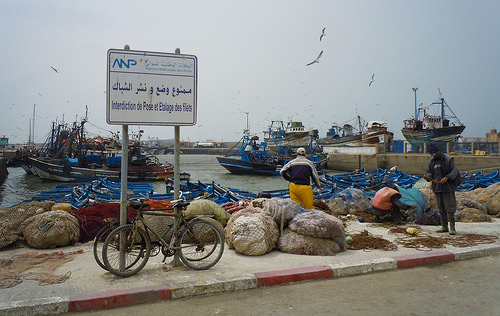<image>
Is there a green water on the sea gull? No. The green water is not positioned on the sea gull. They may be near each other, but the green water is not supported by or resting on top of the sea gull. Is there a sky behind the boat? Yes. From this viewpoint, the sky is positioned behind the boat, with the boat partially or fully occluding the sky. 